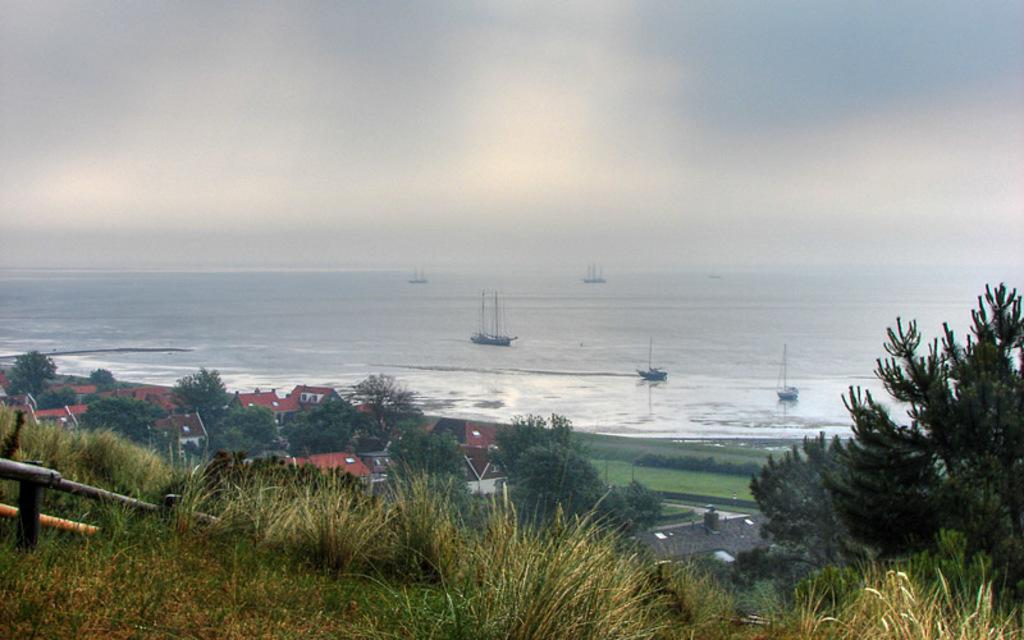What type of vegetation can be seen in the image? There is grass in the image. What is the color of the grass? The grass is green. What other natural elements are present in the image? There are trees in the image. What type of man-made structures can be seen in the image? There are buildings in the image. What can be seen in the background of the image? There are boats on water in the background of the image. Can you see anyone smiling in the image? There is no indication of people or faces in the image, so it is not possible to determine if anyone is smiling. 